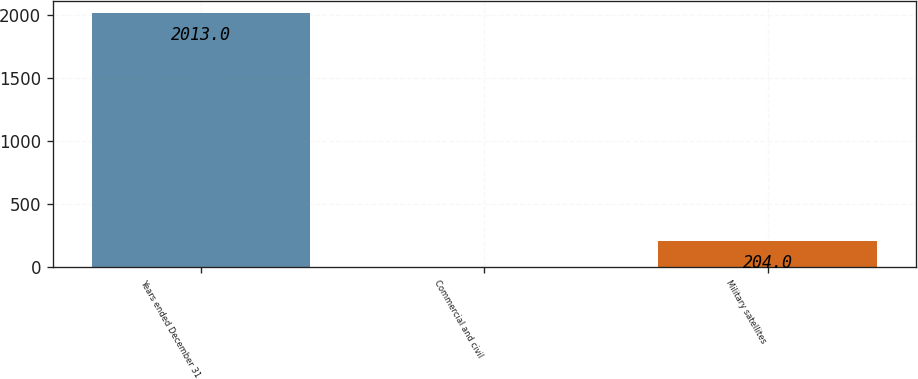Convert chart to OTSL. <chart><loc_0><loc_0><loc_500><loc_500><bar_chart><fcel>Years ended December 31<fcel>Commercial and civil<fcel>Military satellites<nl><fcel>2013<fcel>3<fcel>204<nl></chart> 